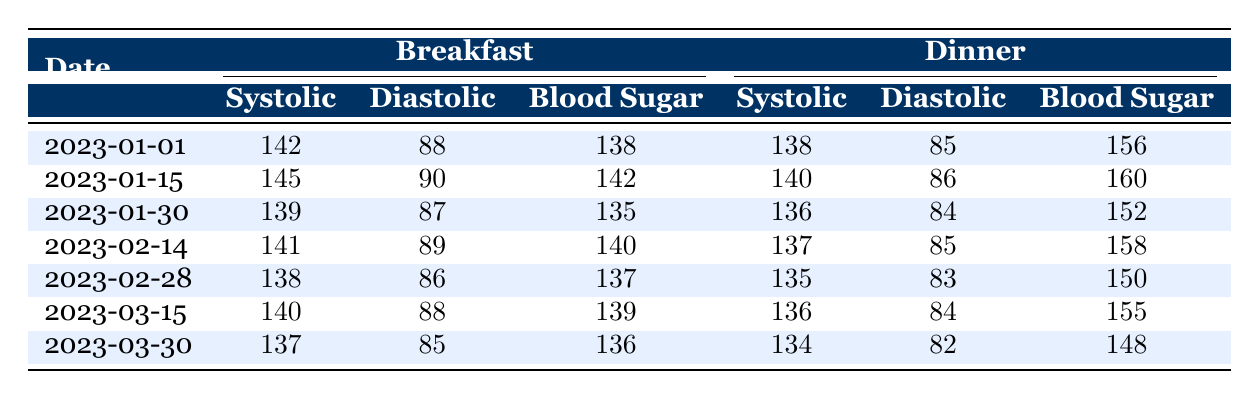What was the systolic blood pressure reading on January 30 for breakfast? The table shows the breakfast data for January 30, which lists a systolic blood pressure of 139.
Answer: 139 What is the blood sugar level for dinner on February 14? From the table, the dinner reading on February 14 states the blood sugar level is 158.
Answer: 158 What is the average systolic blood pressure for breakfast over the recorded days? The systolic blood pressure readings for breakfast are 142, 145, 139, 141, 138, 140, and 137. Summing these gives 142 + 145 + 139 + 141 + 138 + 140 + 137 = 1022. There are 7 readings, so the average is 1022/7 = 146. In rounding, it’s 146.
Answer: 146 Did the blood pressure readings ever exceed 145 for dinner? Observing the dinner readings, the highest systolic blood pressure recorded is 140 on January 15, which does not exceed 145.
Answer: No What is the difference between the highest and lowest blood sugar readings for breakfast? The breakfast blood sugar readings are 138, 142, 140, 137, 139, and 136. The highest reading is 142 and the lowest is 136. The difference is 142 - 136 = 6.
Answer: 6 On which date was the diastolic blood pressure highest for dinner? Looking at the dinner readings, the diastolic blood pressure is 85 on January 1, 86 on January 15, 84 on January 30, 85 on February 14, 83 on February 28, and 84 on March 15, with 82 on March 30. The highest diastolic reading of 86 occurred on January 15.
Answer: January 15 What was the total number of blood sugar readings recorded? The total entries consist of two readings (breakfast and dinner) for each of the 7 dates. Thus, there are 7 * 2 = 14 blood sugar readings accumulated within the table.
Answer: 14 Is there a recorded day where both breakfast and dinner readings showed blood sugar levels over 150? Checking the entries, only on January 15 do both blood sugar readings exceed 150—156 for dinner and 142 for breakfast. So, for breakfast, it is not over, only dinner exceeds 150.
Answer: No 